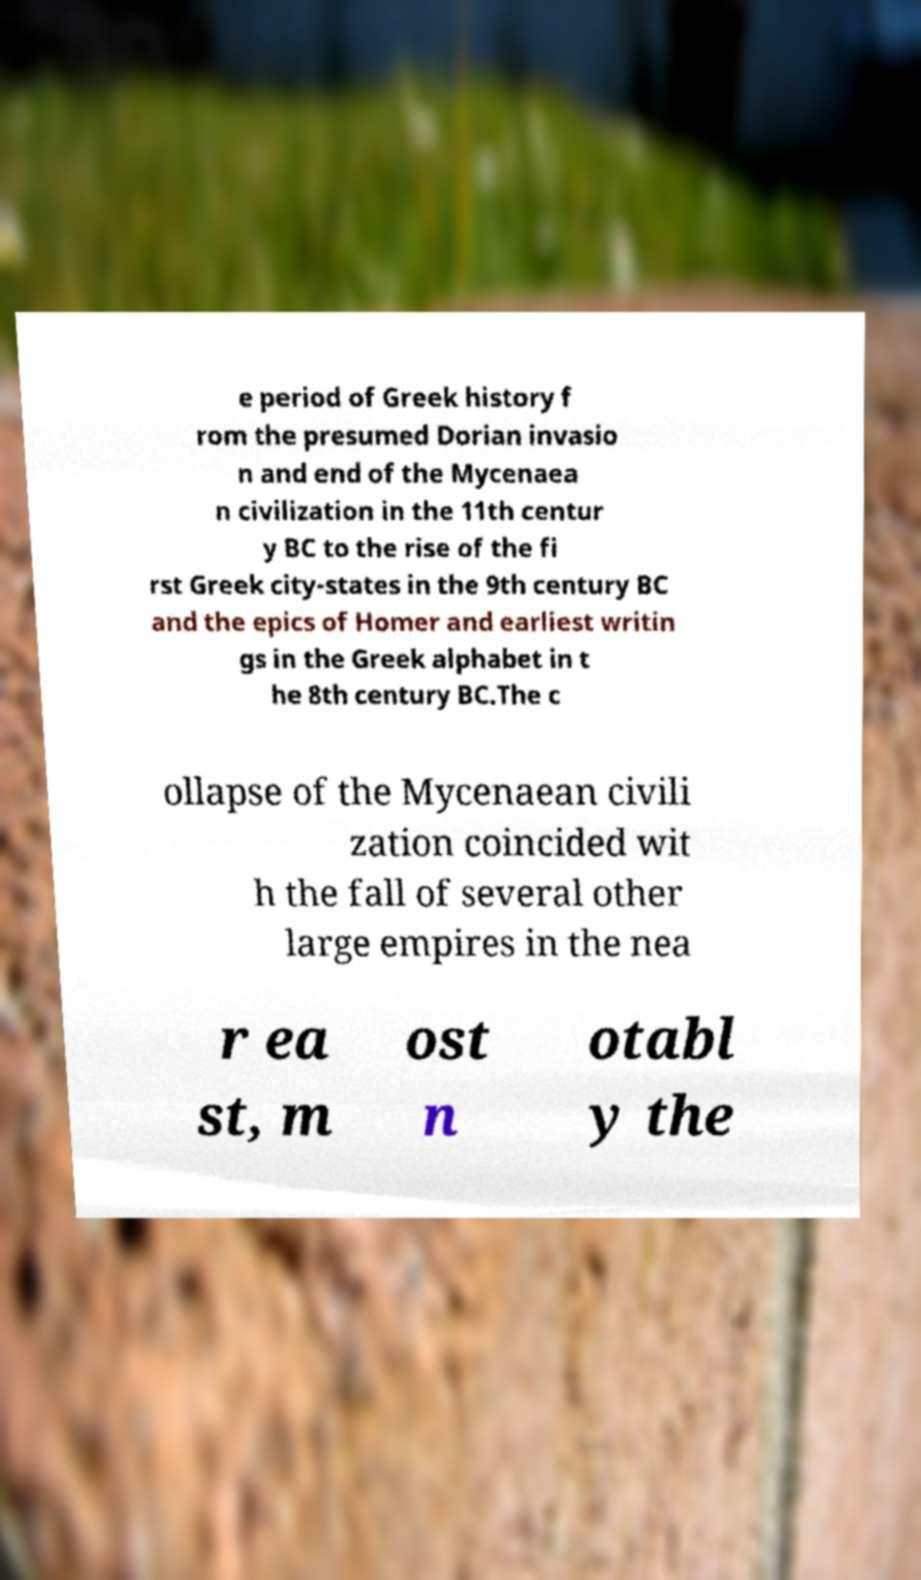Can you read and provide the text displayed in the image?This photo seems to have some interesting text. Can you extract and type it out for me? e period of Greek history f rom the presumed Dorian invasio n and end of the Mycenaea n civilization in the 11th centur y BC to the rise of the fi rst Greek city-states in the 9th century BC and the epics of Homer and earliest writin gs in the Greek alphabet in t he 8th century BC.The c ollapse of the Mycenaean civili zation coincided wit h the fall of several other large empires in the nea r ea st, m ost n otabl y the 